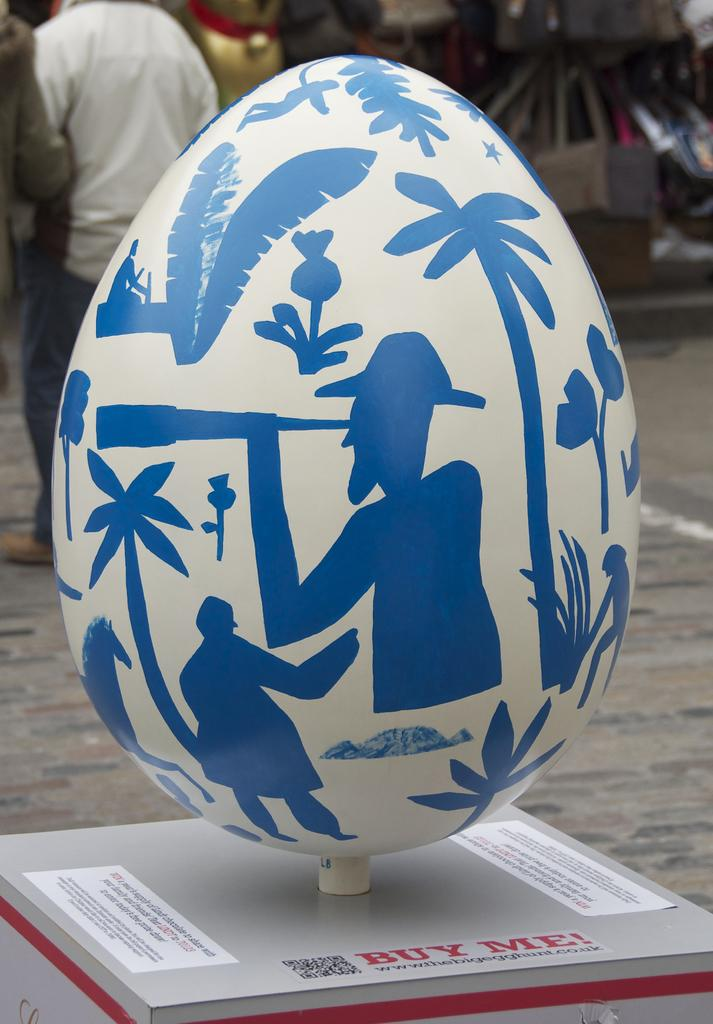What is the main subject in the center of the image? There is a printed model of an egg in the center of the image. What can be seen in the background of the image? There are people and bags in the background of the image. What type of advice can be seen being given by the ant in the image? There is no ant present in the image, so no advice can be given by an ant. 